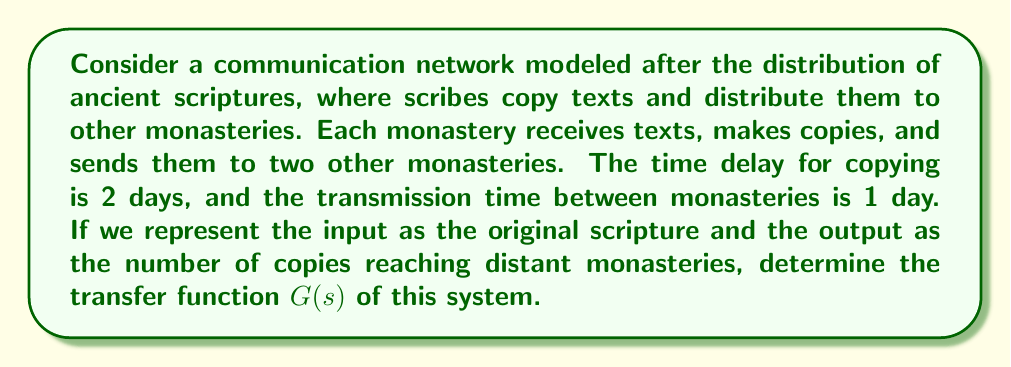Could you help me with this problem? Let's approach this step-by-step:

1) First, we need to model the system. Each monastery receives a text, copies it (delay of 2 days), and sends it to two other monasteries (delay of 1 day each).

2) We can represent this as a block diagram:

   [asy]
   import graph;
   size(200,100);
   
   draw((0,50)--(50,50),Arrow);
   draw((50,30)--(50,70),Box);
   label("Delay 2", (50,50), W);
   draw((50,50)--(100,50),Arrow);
   draw((100,30)--(100,70),Box);
   label("x2", (100,50), E);
   draw((100,70)--(150,70),Arrow);
   draw((100,30)--(150,30),Arrow);
   draw((150,50)--(150,90),Box);
   draw((150,10)--(150,50),Box);
   label("Delay 1", (150,70), E);
   label("Delay 1", (150,30), E);
   draw((150,90)--(200,90),Arrow);
   draw((150,10)--(200,10),Arrow);
   
   label("Input", (0,50), W);
   label("Output", (200,50), E);
   [/asy]

3) In the Laplace domain, a delay of $T$ seconds is represented by $e^{-Ts}$.

4) The transfer function for the copying delay is:
   
   $G_1(s) = e^{-2s}$

5) The transfer function for the transmission delay is:
   
   $G_2(s) = e^{-s}$

6) The multiplication by 2 (as each monastery sends to two others) is represented by a gain of 2.

7) The overall transfer function is:

   $G(s) = 2e^{-2s}e^{-s} = 2e^{-3s}$

This transfer function represents how the input (original scripture) is transformed into the output (copies reaching distant monasteries) in the Laplace domain.
Answer: $G(s) = 2e^{-3s}$ 